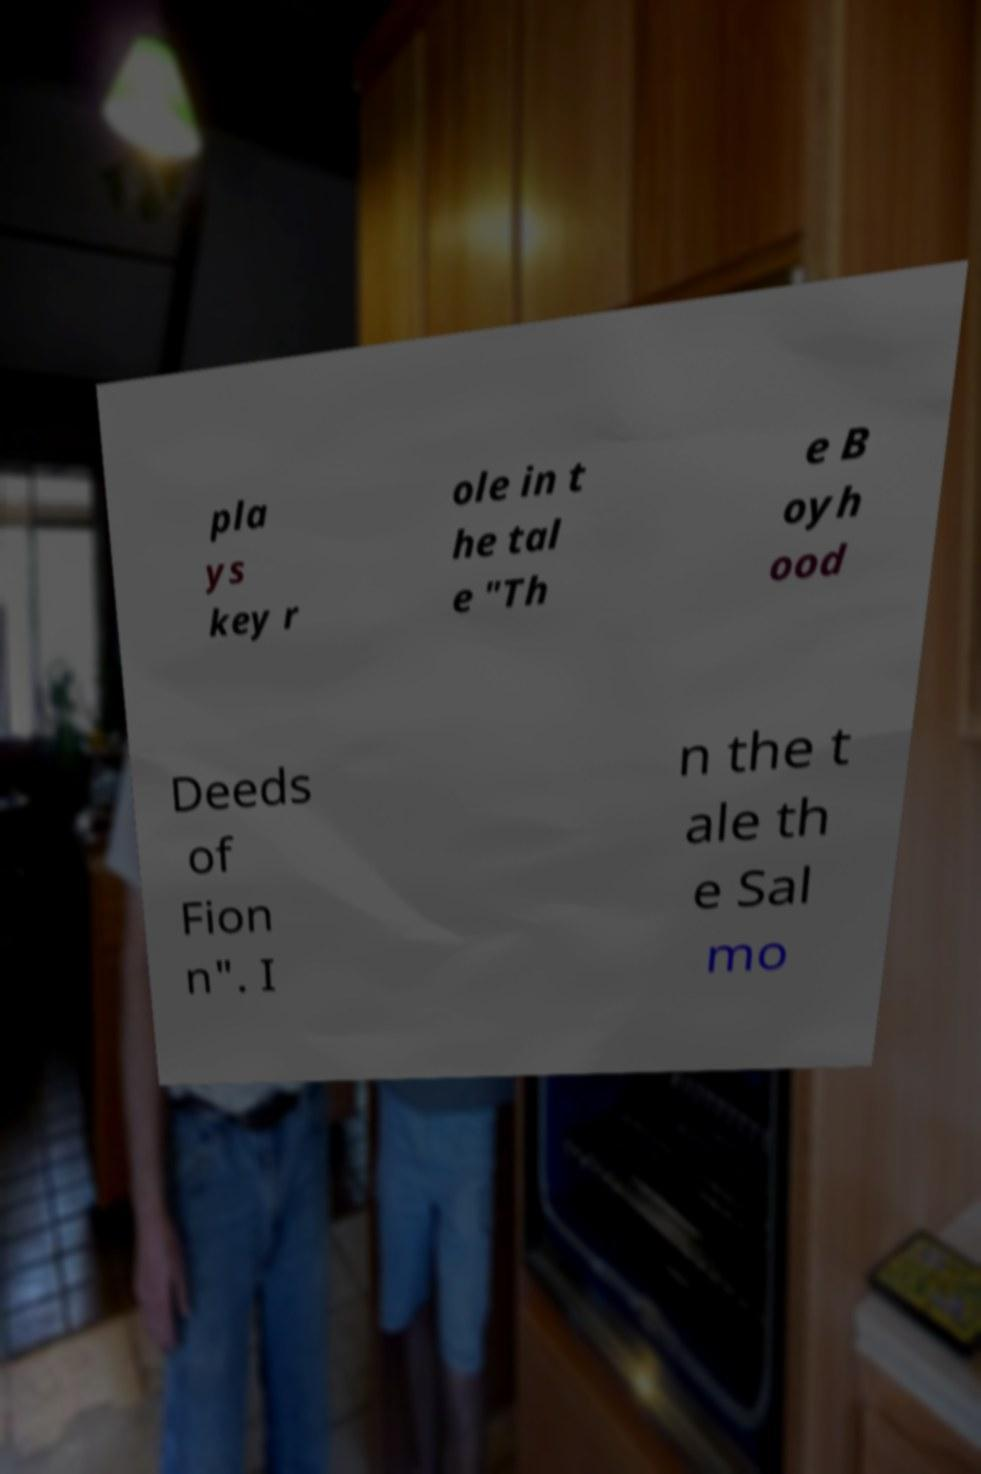What messages or text are displayed in this image? I need them in a readable, typed format. pla ys key r ole in t he tal e "Th e B oyh ood Deeds of Fion n". I n the t ale th e Sal mo 